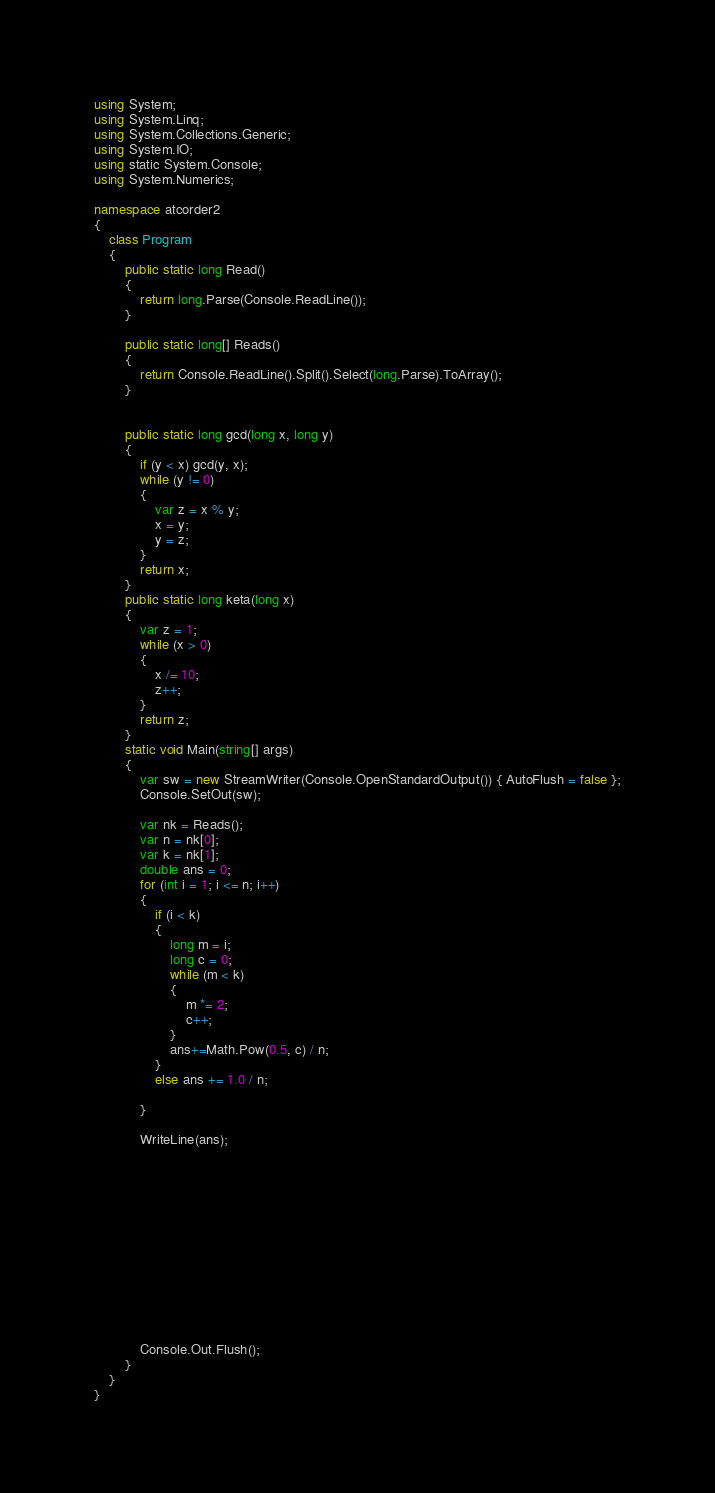Convert code to text. <code><loc_0><loc_0><loc_500><loc_500><_C#_>using System;
using System.Linq;
using System.Collections.Generic;
using System.IO;
using static System.Console;
using System.Numerics;

namespace atcorder2
{
    class Program
    {
        public static long Read()
        {
            return long.Parse(Console.ReadLine());
        }

        public static long[] Reads()
        {
            return Console.ReadLine().Split().Select(long.Parse).ToArray();
        }


        public static long gcd(long x, long y)
        {
            if (y < x) gcd(y, x);
            while (y != 0)
            {
                var z = x % y;
                x = y;
                y = z;
            }
            return x;
        }
        public static long keta(long x)
        {
            var z = 1;
            while (x > 0)
            {
                x /= 10;
                z++;
            }
            return z;
        }
        static void Main(string[] args)
        {
            var sw = new StreamWriter(Console.OpenStandardOutput()) { AutoFlush = false };
            Console.SetOut(sw);

            var nk = Reads();
            var n = nk[0];
            var k = nk[1];
            double ans = 0;
            for (int i = 1; i <= n; i++)
            {
                if (i < k)
                {
                    long m = i;
                    long c = 0;
                    while (m < k)
                    {
                        m *= 2;
                        c++;
                    }
                    ans+=Math.Pow(0.5, c) / n;
                }
                else ans += 1.0 / n;
                
            }

            WriteLine(ans);












          
            Console.Out.Flush();
        }
    }
}

</code> 